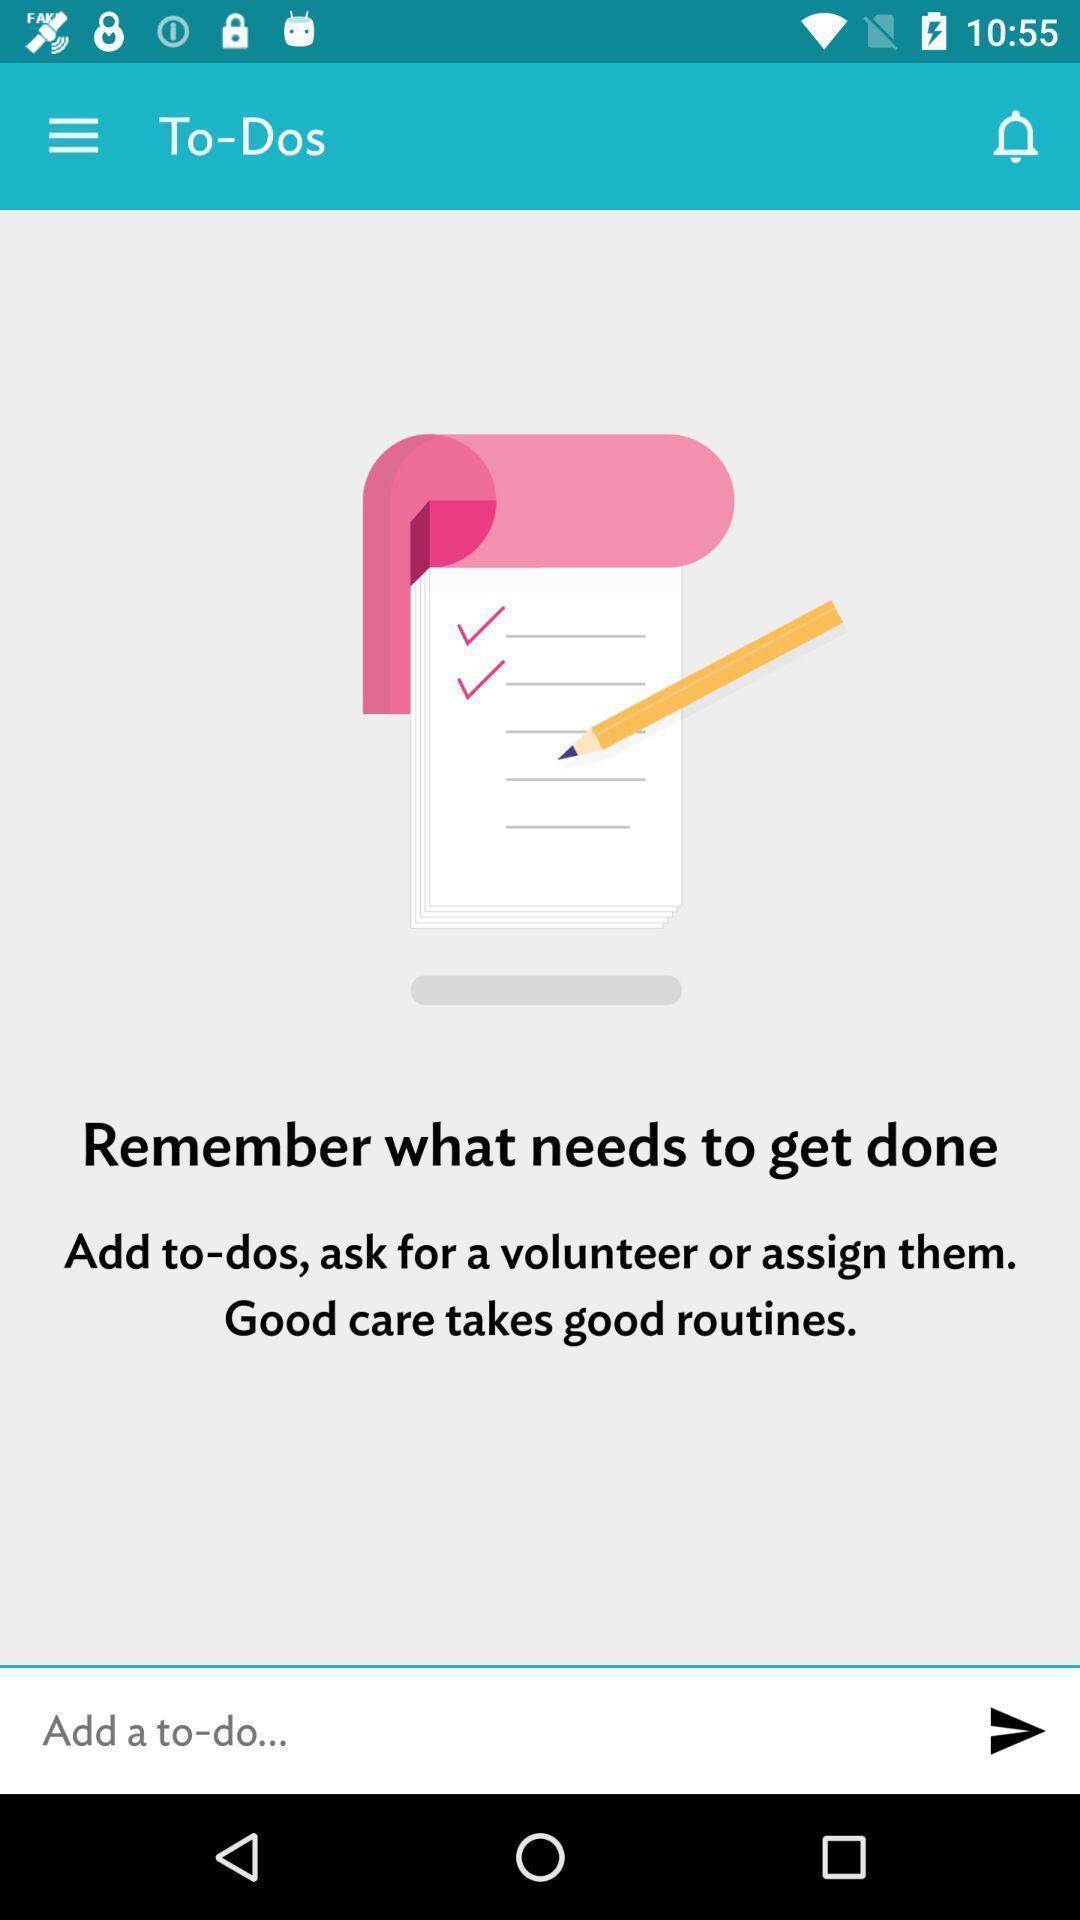Describe the content in this image. Page showing information about to add remember. 